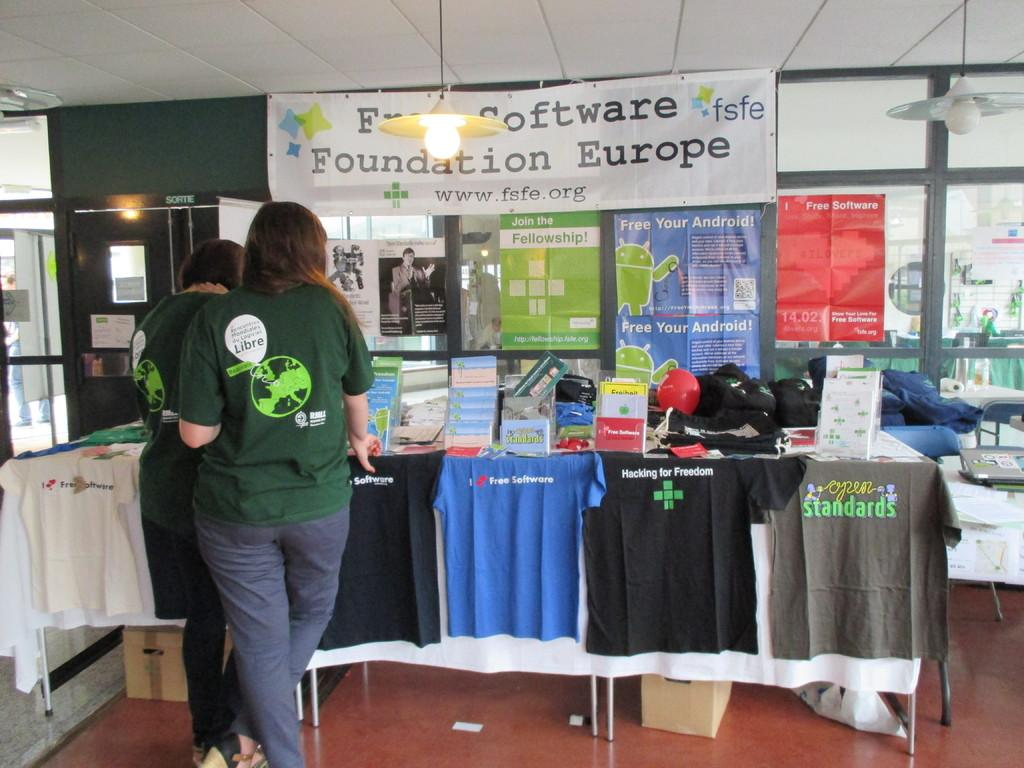Provide a one-sentence caption for the provided image. People stand in line and look at shirts on a table for the Fun Sooftware Foundation of Europe. 